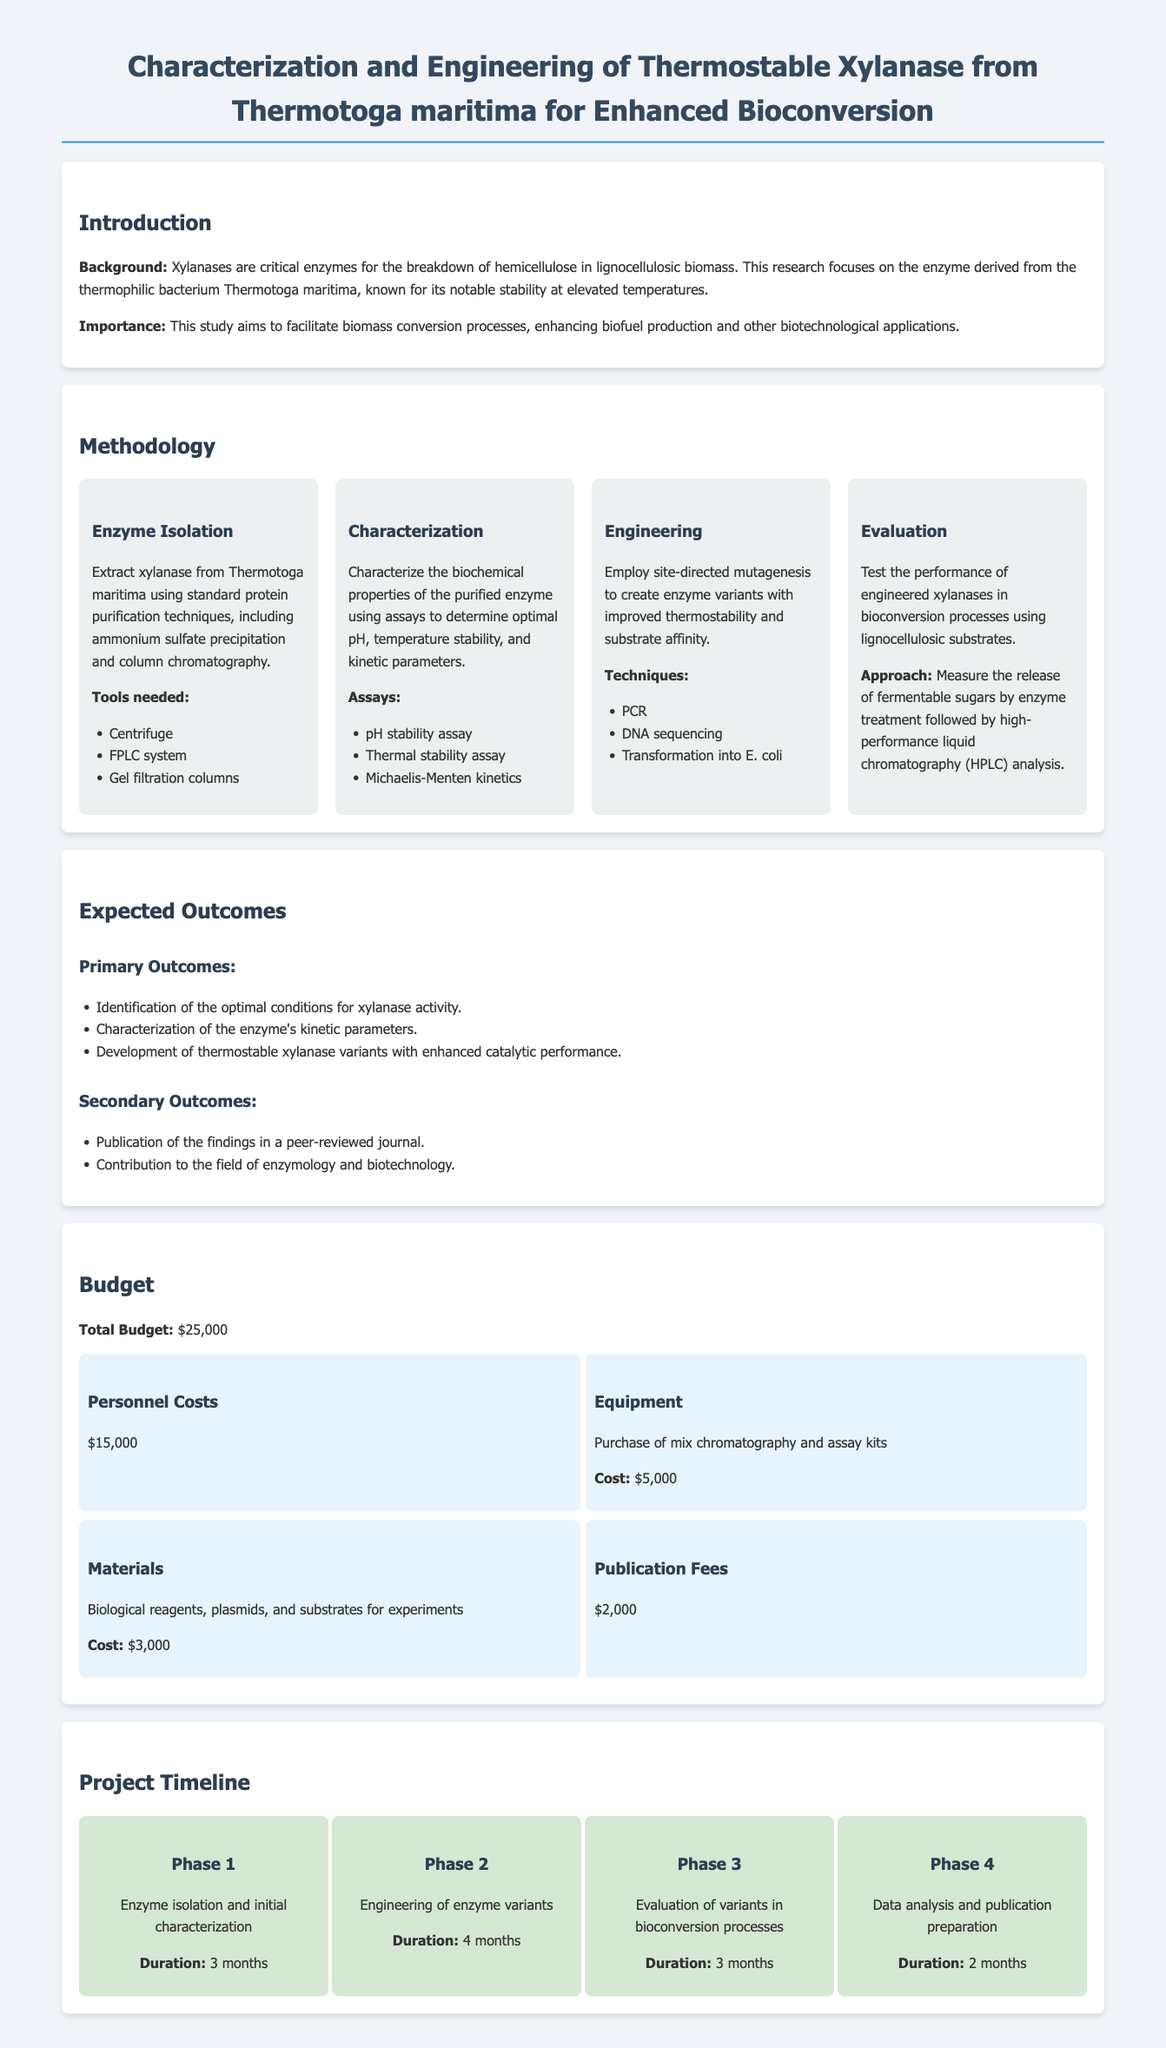What is the title of the research project? The title of the research project can be found at the top of the document.
Answer: Characterization and Engineering of Thermostable Xylanase from Thermotoga maritima for Enhanced Bioconversion Who is the source organism for the xylanase enzyme? The source organism for the enzyme is mentioned in the introduction section.
Answer: Thermotoga maritima What is the total budget for the project? The total budget is stated in the budget section of the document.
Answer: $25,000 How long is the enzyme isolation and initial characterization phase? The duration of the first phase is indicated in the project timeline section.
Answer: 3 months What are the expected primary outcomes? The primary outcomes are listed in the expected outcomes section.
Answer: Identification of the optimal conditions for xylanase activity, characterization of the enzyme's kinetic parameters, development of thermostable xylanase variants with enhanced catalytic performance What purification techniques will be used for enzyme isolation? The purification techniques are specified in the methodology section under enzyme isolation.
Answer: Ammonium sulfate precipitation and column chromatography What type of assay is used to evaluate thermal stability? The type of assay for evaluating thermal stability is listed in the characterization methodology.
Answer: Thermal stability assay What is the cost allocation for personnel costs? The cost allocation is specified in the budget details section.
Answer: $15,000 